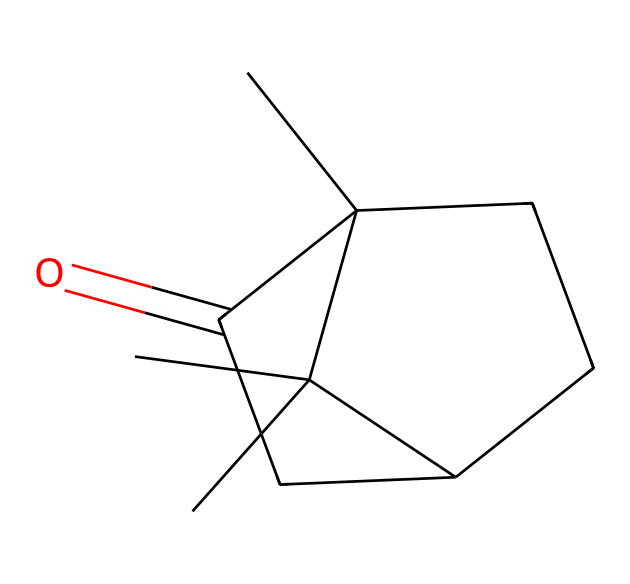How many carbon atoms are present in camphor? The SMILES representation indicates the presence of 10 carbon atoms (C) as each 'C' symbol represents one carbon atom. Counting all 'C' symbols gives 10.
Answer: 10 What is the functional group present in camphor? The molecule contains a carbonyl group (C=O), indicated by the part 'C(=O)' in the SMILES. This identifies camphor as having a ketone functional group.
Answer: ketone How many rings are there in the structure of camphor? By analyzing the SMILES representation, we can identify that it contains two cyclic structures, indicated by the presence of 'C1' and 'C2' which signify the start of rings.
Answer: 2 What type of compound is camphor classified as? The structure of camphor, characterized by carbon chains and rings without any aromatic rings, classifies it as a terpenoid.
Answer: terpenoid Describe the hydrogenation state of camphor based on its structure? Examining the structure, camphor contains multiple sp3 hybridized carbon atoms with single bonds that can bond with hydrogen. The carbonyl group indicates that one of the carbon atoms is bonded to an oxygen, reducing the number of available hydrogens slightly compared to the maximum saturation.
Answer: unsaturated What is the molecular formula of camphor? The structure indicates there are 10 carbons, 16 hydrogens, and 1 oxygen present, thus the molecular formula is derived as C10H16O.
Answer: C10H16O 